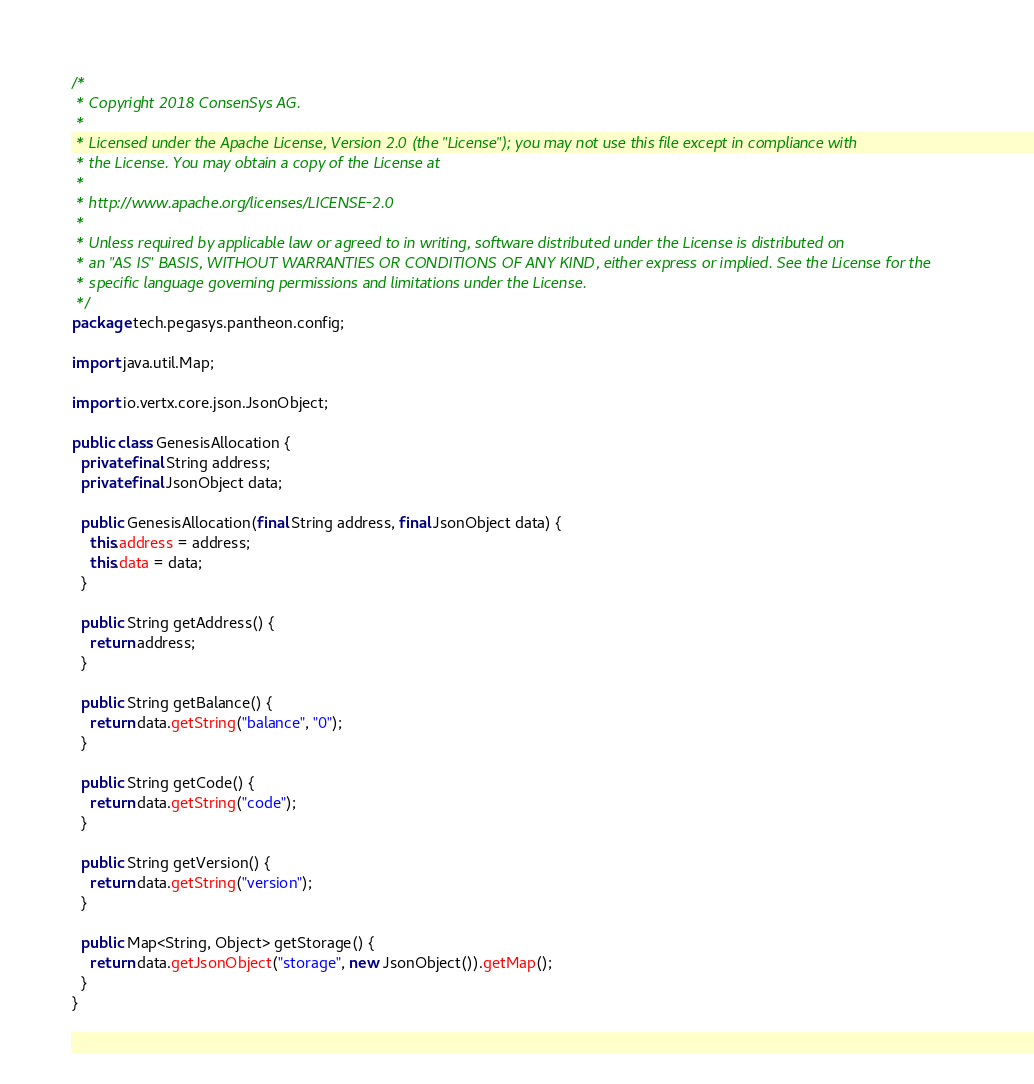<code> <loc_0><loc_0><loc_500><loc_500><_Java_>/*
 * Copyright 2018 ConsenSys AG.
 *
 * Licensed under the Apache License, Version 2.0 (the "License"); you may not use this file except in compliance with
 * the License. You may obtain a copy of the License at
 *
 * http://www.apache.org/licenses/LICENSE-2.0
 *
 * Unless required by applicable law or agreed to in writing, software distributed under the License is distributed on
 * an "AS IS" BASIS, WITHOUT WARRANTIES OR CONDITIONS OF ANY KIND, either express or implied. See the License for the
 * specific language governing permissions and limitations under the License.
 */
package tech.pegasys.pantheon.config;

import java.util.Map;

import io.vertx.core.json.JsonObject;

public class GenesisAllocation {
  private final String address;
  private final JsonObject data;

  public GenesisAllocation(final String address, final JsonObject data) {
    this.address = address;
    this.data = data;
  }

  public String getAddress() {
    return address;
  }

  public String getBalance() {
    return data.getString("balance", "0");
  }

  public String getCode() {
    return data.getString("code");
  }

  public String getVersion() {
    return data.getString("version");
  }

  public Map<String, Object> getStorage() {
    return data.getJsonObject("storage", new JsonObject()).getMap();
  }
}
</code> 